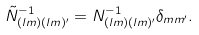<formula> <loc_0><loc_0><loc_500><loc_500>\tilde { N } ^ { - 1 } _ { ( l m ) ( l m ) ^ { \prime } } = N ^ { - 1 } _ { ( l m ) ( l m ) ^ { \prime } } \delta _ { m m ^ { \prime } } .</formula> 